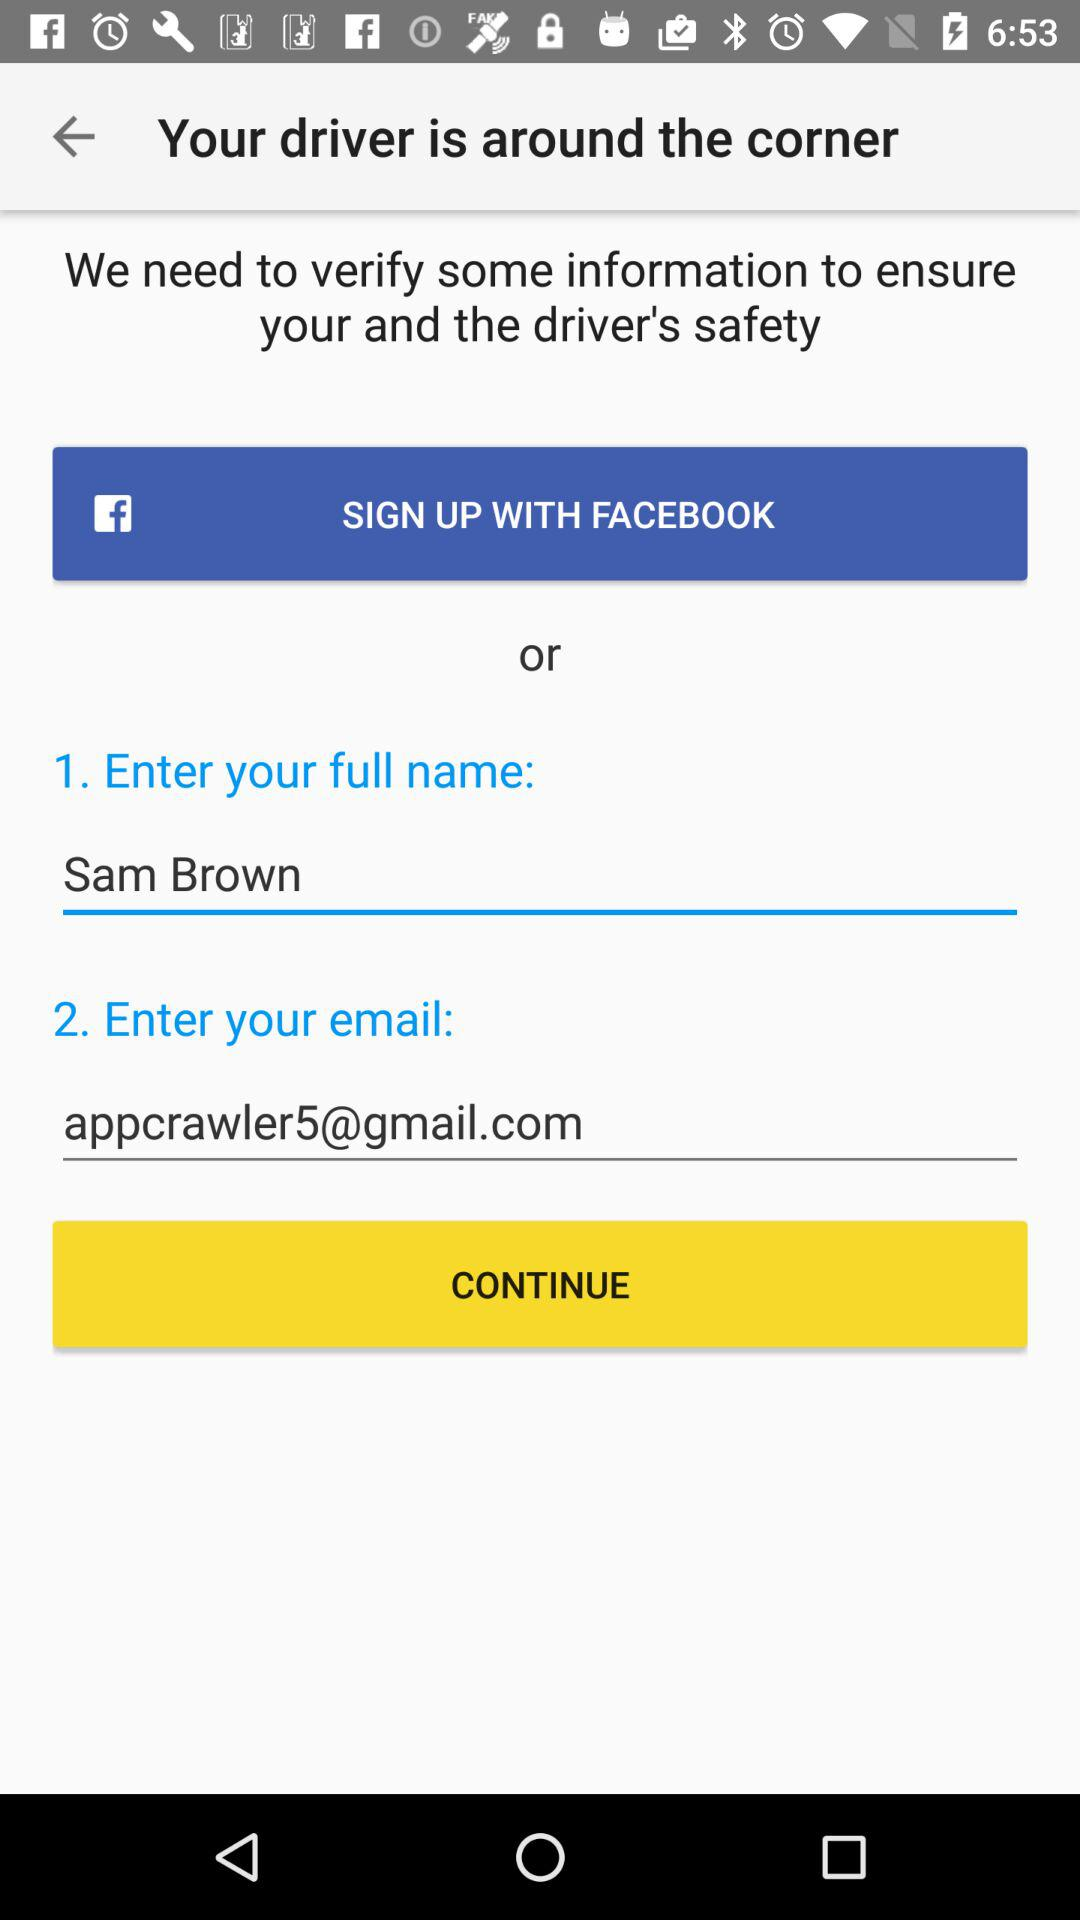How many steps are required to complete this flow?
Answer the question using a single word or phrase. 2 